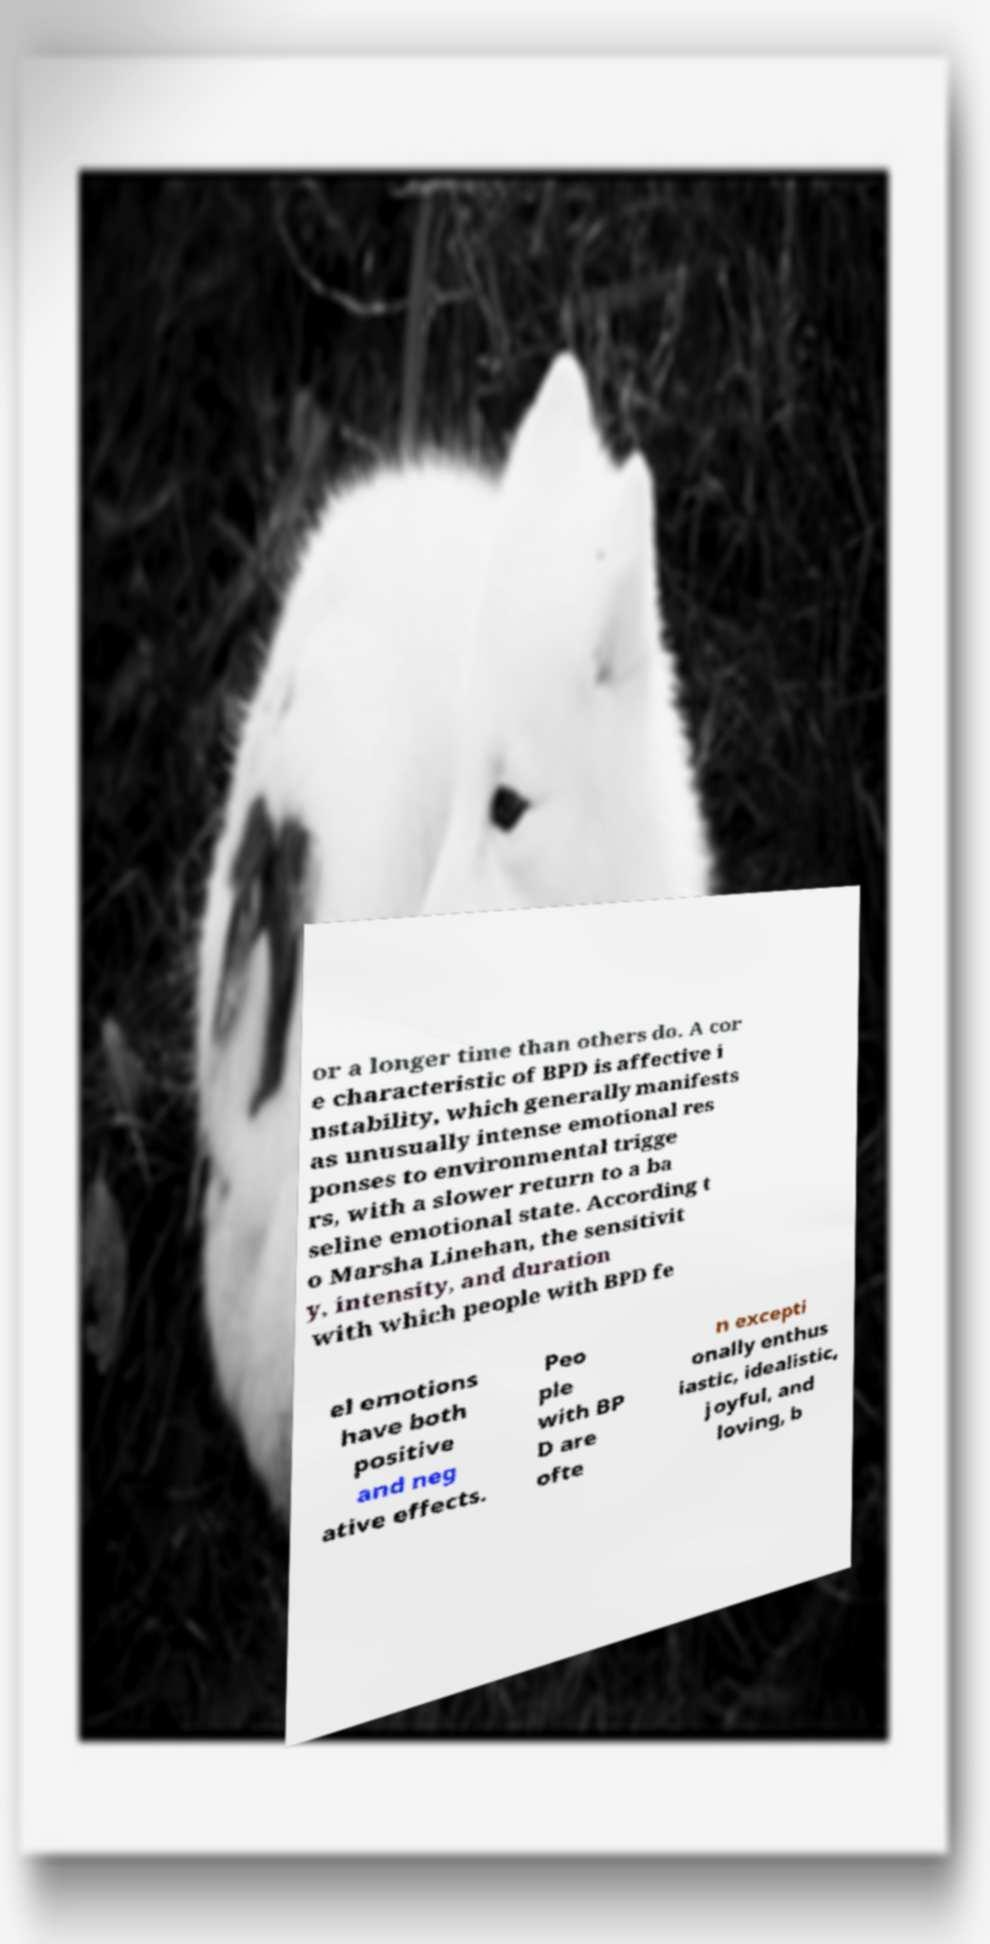Please read and relay the text visible in this image. What does it say? or a longer time than others do. A cor e characteristic of BPD is affective i nstability, which generally manifests as unusually intense emotional res ponses to environmental trigge rs, with a slower return to a ba seline emotional state. According t o Marsha Linehan, the sensitivit y, intensity, and duration with which people with BPD fe el emotions have both positive and neg ative effects. Peo ple with BP D are ofte n excepti onally enthus iastic, idealistic, joyful, and loving, b 